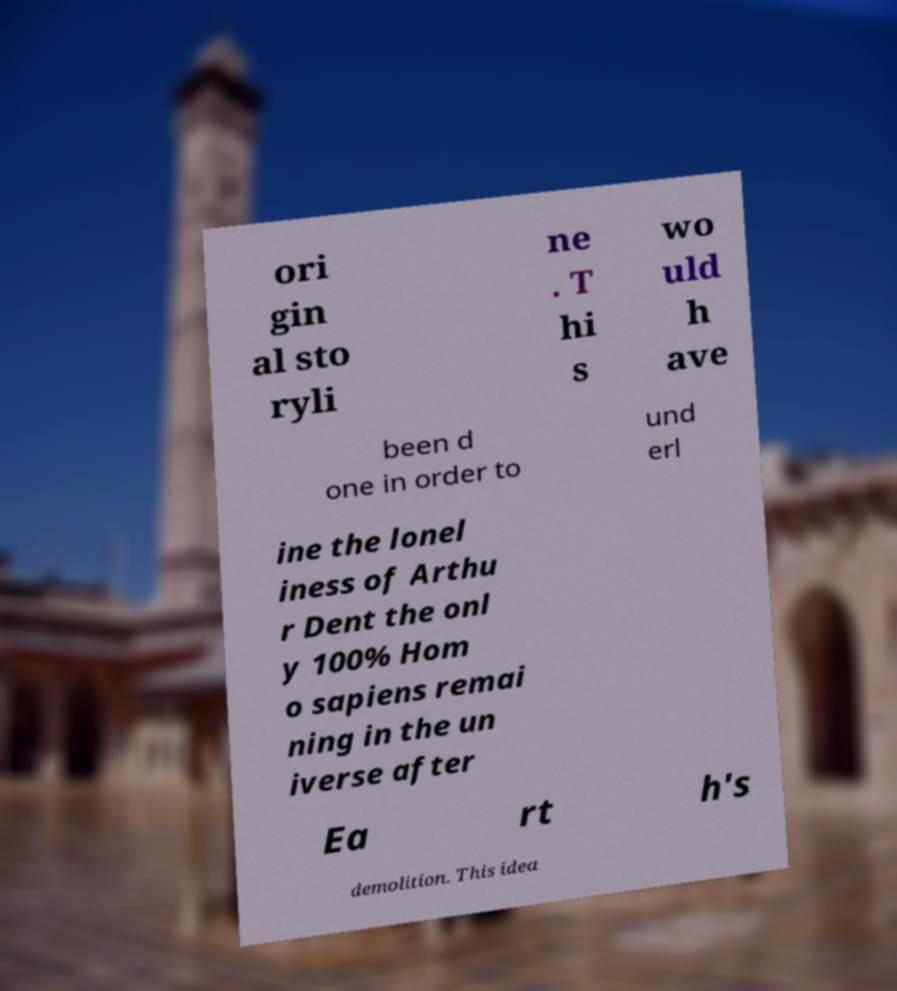Could you assist in decoding the text presented in this image and type it out clearly? ori gin al sto ryli ne . T hi s wo uld h ave been d one in order to und erl ine the lonel iness of Arthu r Dent the onl y 100% Hom o sapiens remai ning in the un iverse after Ea rt h's demolition. This idea 